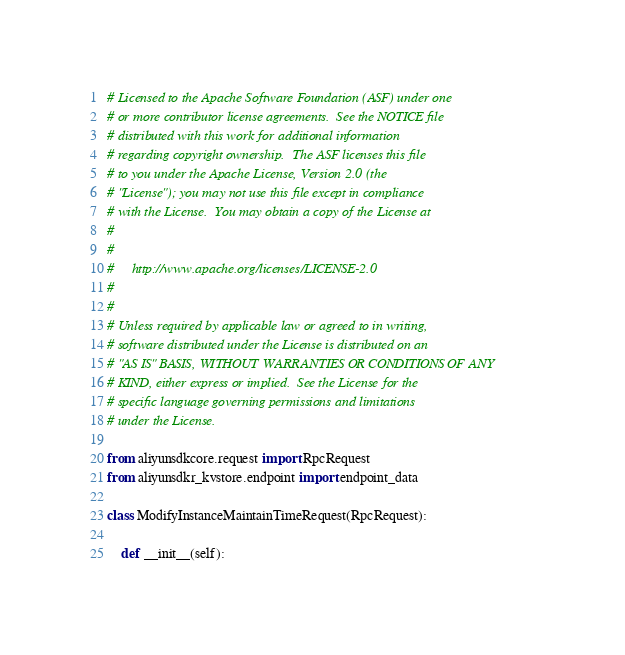<code> <loc_0><loc_0><loc_500><loc_500><_Python_># Licensed to the Apache Software Foundation (ASF) under one
# or more contributor license agreements.  See the NOTICE file
# distributed with this work for additional information
# regarding copyright ownership.  The ASF licenses this file
# to you under the Apache License, Version 2.0 (the
# "License"); you may not use this file except in compliance
# with the License.  You may obtain a copy of the License at
#
#
#     http://www.apache.org/licenses/LICENSE-2.0
#
#
# Unless required by applicable law or agreed to in writing,
# software distributed under the License is distributed on an
# "AS IS" BASIS, WITHOUT WARRANTIES OR CONDITIONS OF ANY
# KIND, either express or implied.  See the License for the
# specific language governing permissions and limitations
# under the License.

from aliyunsdkcore.request import RpcRequest
from aliyunsdkr_kvstore.endpoint import endpoint_data

class ModifyInstanceMaintainTimeRequest(RpcRequest):

	def __init__(self):</code> 